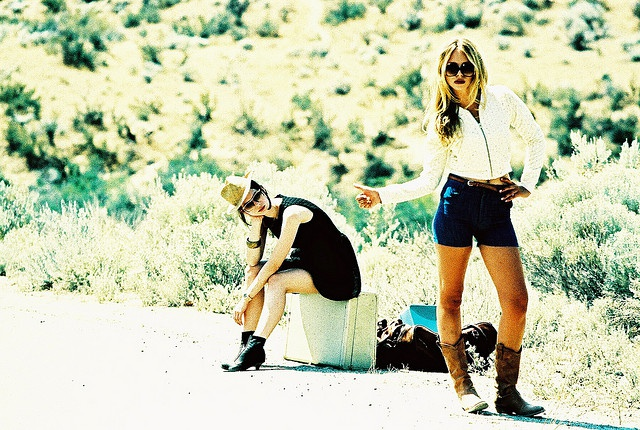Describe the objects in this image and their specific colors. I can see people in darkgreen, beige, black, brown, and khaki tones, people in darkgreen, black, ivory, khaki, and tan tones, suitcase in darkgreen, beige, lightgreen, and darkgray tones, handbag in darkgreen, black, gray, ivory, and darkgray tones, and handbag in darkgreen, black, ivory, darkgray, and gray tones in this image. 